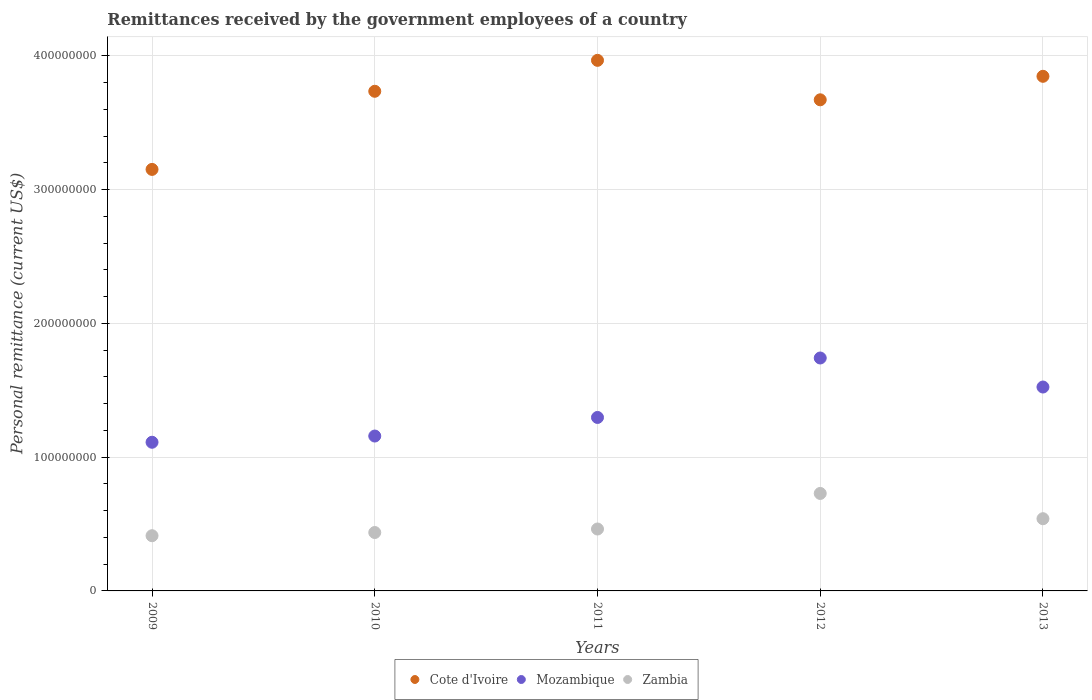How many different coloured dotlines are there?
Your response must be concise. 3. What is the remittances received by the government employees in Mozambique in 2013?
Give a very brief answer. 1.52e+08. Across all years, what is the maximum remittances received by the government employees in Cote d'Ivoire?
Provide a succinct answer. 3.97e+08. Across all years, what is the minimum remittances received by the government employees in Zambia?
Ensure brevity in your answer.  4.13e+07. In which year was the remittances received by the government employees in Zambia maximum?
Your answer should be very brief. 2012. What is the total remittances received by the government employees in Mozambique in the graph?
Give a very brief answer. 6.83e+08. What is the difference between the remittances received by the government employees in Mozambique in 2009 and that in 2012?
Keep it short and to the point. -6.30e+07. What is the difference between the remittances received by the government employees in Cote d'Ivoire in 2011 and the remittances received by the government employees in Zambia in 2012?
Your response must be concise. 3.24e+08. What is the average remittances received by the government employees in Zambia per year?
Offer a very short reply. 5.16e+07. In the year 2010, what is the difference between the remittances received by the government employees in Zambia and remittances received by the government employees in Cote d'Ivoire?
Ensure brevity in your answer.  -3.30e+08. In how many years, is the remittances received by the government employees in Cote d'Ivoire greater than 220000000 US$?
Keep it short and to the point. 5. What is the ratio of the remittances received by the government employees in Zambia in 2011 to that in 2013?
Ensure brevity in your answer.  0.86. Is the remittances received by the government employees in Cote d'Ivoire in 2010 less than that in 2012?
Offer a very short reply. No. Is the difference between the remittances received by the government employees in Zambia in 2009 and 2010 greater than the difference between the remittances received by the government employees in Cote d'Ivoire in 2009 and 2010?
Provide a short and direct response. Yes. What is the difference between the highest and the second highest remittances received by the government employees in Cote d'Ivoire?
Your answer should be very brief. 1.19e+07. What is the difference between the highest and the lowest remittances received by the government employees in Mozambique?
Provide a short and direct response. 6.30e+07. Is the remittances received by the government employees in Cote d'Ivoire strictly greater than the remittances received by the government employees in Mozambique over the years?
Your answer should be very brief. Yes. Is the remittances received by the government employees in Zambia strictly less than the remittances received by the government employees in Cote d'Ivoire over the years?
Your response must be concise. Yes. How many dotlines are there?
Your answer should be very brief. 3. How many years are there in the graph?
Your answer should be very brief. 5. What is the difference between two consecutive major ticks on the Y-axis?
Keep it short and to the point. 1.00e+08. Are the values on the major ticks of Y-axis written in scientific E-notation?
Provide a succinct answer. No. How many legend labels are there?
Offer a terse response. 3. How are the legend labels stacked?
Provide a short and direct response. Horizontal. What is the title of the graph?
Make the answer very short. Remittances received by the government employees of a country. What is the label or title of the Y-axis?
Offer a very short reply. Personal remittance (current US$). What is the Personal remittance (current US$) in Cote d'Ivoire in 2009?
Your response must be concise. 3.15e+08. What is the Personal remittance (current US$) of Mozambique in 2009?
Your response must be concise. 1.11e+08. What is the Personal remittance (current US$) in Zambia in 2009?
Your answer should be very brief. 4.13e+07. What is the Personal remittance (current US$) in Cote d'Ivoire in 2010?
Provide a succinct answer. 3.73e+08. What is the Personal remittance (current US$) in Mozambique in 2010?
Your answer should be compact. 1.16e+08. What is the Personal remittance (current US$) of Zambia in 2010?
Your answer should be compact. 4.37e+07. What is the Personal remittance (current US$) in Cote d'Ivoire in 2011?
Make the answer very short. 3.97e+08. What is the Personal remittance (current US$) of Mozambique in 2011?
Offer a terse response. 1.30e+08. What is the Personal remittance (current US$) in Zambia in 2011?
Provide a succinct answer. 4.63e+07. What is the Personal remittance (current US$) of Cote d'Ivoire in 2012?
Offer a terse response. 3.67e+08. What is the Personal remittance (current US$) in Mozambique in 2012?
Offer a terse response. 1.74e+08. What is the Personal remittance (current US$) in Zambia in 2012?
Provide a short and direct response. 7.29e+07. What is the Personal remittance (current US$) of Cote d'Ivoire in 2013?
Your answer should be compact. 3.85e+08. What is the Personal remittance (current US$) of Mozambique in 2013?
Offer a very short reply. 1.52e+08. What is the Personal remittance (current US$) of Zambia in 2013?
Give a very brief answer. 5.40e+07. Across all years, what is the maximum Personal remittance (current US$) in Cote d'Ivoire?
Provide a succinct answer. 3.97e+08. Across all years, what is the maximum Personal remittance (current US$) in Mozambique?
Your answer should be very brief. 1.74e+08. Across all years, what is the maximum Personal remittance (current US$) in Zambia?
Give a very brief answer. 7.29e+07. Across all years, what is the minimum Personal remittance (current US$) of Cote d'Ivoire?
Make the answer very short. 3.15e+08. Across all years, what is the minimum Personal remittance (current US$) in Mozambique?
Your answer should be compact. 1.11e+08. Across all years, what is the minimum Personal remittance (current US$) of Zambia?
Ensure brevity in your answer.  4.13e+07. What is the total Personal remittance (current US$) in Cote d'Ivoire in the graph?
Your response must be concise. 1.84e+09. What is the total Personal remittance (current US$) in Mozambique in the graph?
Offer a very short reply. 6.83e+08. What is the total Personal remittance (current US$) of Zambia in the graph?
Your answer should be very brief. 2.58e+08. What is the difference between the Personal remittance (current US$) in Cote d'Ivoire in 2009 and that in 2010?
Provide a succinct answer. -5.84e+07. What is the difference between the Personal remittance (current US$) of Mozambique in 2009 and that in 2010?
Keep it short and to the point. -4.65e+06. What is the difference between the Personal remittance (current US$) in Zambia in 2009 and that in 2010?
Your response must be concise. -2.39e+06. What is the difference between the Personal remittance (current US$) of Cote d'Ivoire in 2009 and that in 2011?
Offer a very short reply. -8.15e+07. What is the difference between the Personal remittance (current US$) in Mozambique in 2009 and that in 2011?
Provide a succinct answer. -1.85e+07. What is the difference between the Personal remittance (current US$) of Zambia in 2009 and that in 2011?
Keep it short and to the point. -5.01e+06. What is the difference between the Personal remittance (current US$) in Cote d'Ivoire in 2009 and that in 2012?
Your answer should be very brief. -5.20e+07. What is the difference between the Personal remittance (current US$) in Mozambique in 2009 and that in 2012?
Your answer should be compact. -6.30e+07. What is the difference between the Personal remittance (current US$) of Zambia in 2009 and that in 2012?
Provide a short and direct response. -3.16e+07. What is the difference between the Personal remittance (current US$) in Cote d'Ivoire in 2009 and that in 2013?
Provide a succinct answer. -6.96e+07. What is the difference between the Personal remittance (current US$) in Mozambique in 2009 and that in 2013?
Give a very brief answer. -4.13e+07. What is the difference between the Personal remittance (current US$) in Zambia in 2009 and that in 2013?
Offer a terse response. -1.27e+07. What is the difference between the Personal remittance (current US$) of Cote d'Ivoire in 2010 and that in 2011?
Provide a succinct answer. -2.31e+07. What is the difference between the Personal remittance (current US$) in Mozambique in 2010 and that in 2011?
Give a very brief answer. -1.39e+07. What is the difference between the Personal remittance (current US$) in Zambia in 2010 and that in 2011?
Offer a very short reply. -2.62e+06. What is the difference between the Personal remittance (current US$) in Cote d'Ivoire in 2010 and that in 2012?
Offer a terse response. 6.37e+06. What is the difference between the Personal remittance (current US$) of Mozambique in 2010 and that in 2012?
Keep it short and to the point. -5.83e+07. What is the difference between the Personal remittance (current US$) in Zambia in 2010 and that in 2012?
Provide a succinct answer. -2.92e+07. What is the difference between the Personal remittance (current US$) of Cote d'Ivoire in 2010 and that in 2013?
Make the answer very short. -1.12e+07. What is the difference between the Personal remittance (current US$) of Mozambique in 2010 and that in 2013?
Ensure brevity in your answer.  -3.66e+07. What is the difference between the Personal remittance (current US$) in Zambia in 2010 and that in 2013?
Give a very brief answer. -1.03e+07. What is the difference between the Personal remittance (current US$) of Cote d'Ivoire in 2011 and that in 2012?
Keep it short and to the point. 2.95e+07. What is the difference between the Personal remittance (current US$) in Mozambique in 2011 and that in 2012?
Your answer should be very brief. -4.44e+07. What is the difference between the Personal remittance (current US$) in Zambia in 2011 and that in 2012?
Offer a terse response. -2.66e+07. What is the difference between the Personal remittance (current US$) of Cote d'Ivoire in 2011 and that in 2013?
Make the answer very short. 1.19e+07. What is the difference between the Personal remittance (current US$) of Mozambique in 2011 and that in 2013?
Your answer should be compact. -2.27e+07. What is the difference between the Personal remittance (current US$) in Zambia in 2011 and that in 2013?
Offer a very short reply. -7.70e+06. What is the difference between the Personal remittance (current US$) of Cote d'Ivoire in 2012 and that in 2013?
Make the answer very short. -1.76e+07. What is the difference between the Personal remittance (current US$) in Mozambique in 2012 and that in 2013?
Your answer should be very brief. 2.17e+07. What is the difference between the Personal remittance (current US$) in Zambia in 2012 and that in 2013?
Offer a very short reply. 1.89e+07. What is the difference between the Personal remittance (current US$) of Cote d'Ivoire in 2009 and the Personal remittance (current US$) of Mozambique in 2010?
Your answer should be compact. 1.99e+08. What is the difference between the Personal remittance (current US$) of Cote d'Ivoire in 2009 and the Personal remittance (current US$) of Zambia in 2010?
Provide a short and direct response. 2.71e+08. What is the difference between the Personal remittance (current US$) in Mozambique in 2009 and the Personal remittance (current US$) in Zambia in 2010?
Your answer should be compact. 6.75e+07. What is the difference between the Personal remittance (current US$) in Cote d'Ivoire in 2009 and the Personal remittance (current US$) in Mozambique in 2011?
Ensure brevity in your answer.  1.85e+08. What is the difference between the Personal remittance (current US$) of Cote d'Ivoire in 2009 and the Personal remittance (current US$) of Zambia in 2011?
Your response must be concise. 2.69e+08. What is the difference between the Personal remittance (current US$) of Mozambique in 2009 and the Personal remittance (current US$) of Zambia in 2011?
Provide a short and direct response. 6.48e+07. What is the difference between the Personal remittance (current US$) of Cote d'Ivoire in 2009 and the Personal remittance (current US$) of Mozambique in 2012?
Make the answer very short. 1.41e+08. What is the difference between the Personal remittance (current US$) in Cote d'Ivoire in 2009 and the Personal remittance (current US$) in Zambia in 2012?
Your answer should be very brief. 2.42e+08. What is the difference between the Personal remittance (current US$) of Mozambique in 2009 and the Personal remittance (current US$) of Zambia in 2012?
Your answer should be very brief. 3.83e+07. What is the difference between the Personal remittance (current US$) in Cote d'Ivoire in 2009 and the Personal remittance (current US$) in Mozambique in 2013?
Offer a very short reply. 1.63e+08. What is the difference between the Personal remittance (current US$) in Cote d'Ivoire in 2009 and the Personal remittance (current US$) in Zambia in 2013?
Make the answer very short. 2.61e+08. What is the difference between the Personal remittance (current US$) of Mozambique in 2009 and the Personal remittance (current US$) of Zambia in 2013?
Give a very brief answer. 5.71e+07. What is the difference between the Personal remittance (current US$) of Cote d'Ivoire in 2010 and the Personal remittance (current US$) of Mozambique in 2011?
Ensure brevity in your answer.  2.44e+08. What is the difference between the Personal remittance (current US$) in Cote d'Ivoire in 2010 and the Personal remittance (current US$) in Zambia in 2011?
Offer a very short reply. 3.27e+08. What is the difference between the Personal remittance (current US$) of Mozambique in 2010 and the Personal remittance (current US$) of Zambia in 2011?
Ensure brevity in your answer.  6.95e+07. What is the difference between the Personal remittance (current US$) in Cote d'Ivoire in 2010 and the Personal remittance (current US$) in Mozambique in 2012?
Provide a succinct answer. 1.99e+08. What is the difference between the Personal remittance (current US$) in Cote d'Ivoire in 2010 and the Personal remittance (current US$) in Zambia in 2012?
Your answer should be compact. 3.01e+08. What is the difference between the Personal remittance (current US$) of Mozambique in 2010 and the Personal remittance (current US$) of Zambia in 2012?
Ensure brevity in your answer.  4.29e+07. What is the difference between the Personal remittance (current US$) of Cote d'Ivoire in 2010 and the Personal remittance (current US$) of Mozambique in 2013?
Your answer should be compact. 2.21e+08. What is the difference between the Personal remittance (current US$) of Cote d'Ivoire in 2010 and the Personal remittance (current US$) of Zambia in 2013?
Offer a very short reply. 3.19e+08. What is the difference between the Personal remittance (current US$) of Mozambique in 2010 and the Personal remittance (current US$) of Zambia in 2013?
Offer a very short reply. 6.18e+07. What is the difference between the Personal remittance (current US$) in Cote d'Ivoire in 2011 and the Personal remittance (current US$) in Mozambique in 2012?
Your response must be concise. 2.22e+08. What is the difference between the Personal remittance (current US$) in Cote d'Ivoire in 2011 and the Personal remittance (current US$) in Zambia in 2012?
Offer a very short reply. 3.24e+08. What is the difference between the Personal remittance (current US$) of Mozambique in 2011 and the Personal remittance (current US$) of Zambia in 2012?
Keep it short and to the point. 5.68e+07. What is the difference between the Personal remittance (current US$) in Cote d'Ivoire in 2011 and the Personal remittance (current US$) in Mozambique in 2013?
Offer a terse response. 2.44e+08. What is the difference between the Personal remittance (current US$) of Cote d'Ivoire in 2011 and the Personal remittance (current US$) of Zambia in 2013?
Keep it short and to the point. 3.43e+08. What is the difference between the Personal remittance (current US$) of Mozambique in 2011 and the Personal remittance (current US$) of Zambia in 2013?
Provide a short and direct response. 7.57e+07. What is the difference between the Personal remittance (current US$) in Cote d'Ivoire in 2012 and the Personal remittance (current US$) in Mozambique in 2013?
Ensure brevity in your answer.  2.15e+08. What is the difference between the Personal remittance (current US$) in Cote d'Ivoire in 2012 and the Personal remittance (current US$) in Zambia in 2013?
Offer a very short reply. 3.13e+08. What is the difference between the Personal remittance (current US$) of Mozambique in 2012 and the Personal remittance (current US$) of Zambia in 2013?
Provide a succinct answer. 1.20e+08. What is the average Personal remittance (current US$) of Cote d'Ivoire per year?
Give a very brief answer. 3.67e+08. What is the average Personal remittance (current US$) in Mozambique per year?
Give a very brief answer. 1.37e+08. What is the average Personal remittance (current US$) of Zambia per year?
Keep it short and to the point. 5.16e+07. In the year 2009, what is the difference between the Personal remittance (current US$) of Cote d'Ivoire and Personal remittance (current US$) of Mozambique?
Provide a short and direct response. 2.04e+08. In the year 2009, what is the difference between the Personal remittance (current US$) in Cote d'Ivoire and Personal remittance (current US$) in Zambia?
Provide a succinct answer. 2.74e+08. In the year 2009, what is the difference between the Personal remittance (current US$) in Mozambique and Personal remittance (current US$) in Zambia?
Your answer should be compact. 6.99e+07. In the year 2010, what is the difference between the Personal remittance (current US$) of Cote d'Ivoire and Personal remittance (current US$) of Mozambique?
Offer a terse response. 2.58e+08. In the year 2010, what is the difference between the Personal remittance (current US$) of Cote d'Ivoire and Personal remittance (current US$) of Zambia?
Offer a very short reply. 3.30e+08. In the year 2010, what is the difference between the Personal remittance (current US$) in Mozambique and Personal remittance (current US$) in Zambia?
Ensure brevity in your answer.  7.21e+07. In the year 2011, what is the difference between the Personal remittance (current US$) of Cote d'Ivoire and Personal remittance (current US$) of Mozambique?
Your response must be concise. 2.67e+08. In the year 2011, what is the difference between the Personal remittance (current US$) of Cote d'Ivoire and Personal remittance (current US$) of Zambia?
Your answer should be compact. 3.50e+08. In the year 2011, what is the difference between the Personal remittance (current US$) of Mozambique and Personal remittance (current US$) of Zambia?
Your response must be concise. 8.34e+07. In the year 2012, what is the difference between the Personal remittance (current US$) of Cote d'Ivoire and Personal remittance (current US$) of Mozambique?
Your answer should be compact. 1.93e+08. In the year 2012, what is the difference between the Personal remittance (current US$) in Cote d'Ivoire and Personal remittance (current US$) in Zambia?
Give a very brief answer. 2.94e+08. In the year 2012, what is the difference between the Personal remittance (current US$) in Mozambique and Personal remittance (current US$) in Zambia?
Your answer should be very brief. 1.01e+08. In the year 2013, what is the difference between the Personal remittance (current US$) of Cote d'Ivoire and Personal remittance (current US$) of Mozambique?
Ensure brevity in your answer.  2.32e+08. In the year 2013, what is the difference between the Personal remittance (current US$) in Cote d'Ivoire and Personal remittance (current US$) in Zambia?
Offer a terse response. 3.31e+08. In the year 2013, what is the difference between the Personal remittance (current US$) of Mozambique and Personal remittance (current US$) of Zambia?
Your answer should be compact. 9.84e+07. What is the ratio of the Personal remittance (current US$) of Cote d'Ivoire in 2009 to that in 2010?
Make the answer very short. 0.84. What is the ratio of the Personal remittance (current US$) of Mozambique in 2009 to that in 2010?
Your answer should be very brief. 0.96. What is the ratio of the Personal remittance (current US$) of Zambia in 2009 to that in 2010?
Provide a short and direct response. 0.95. What is the ratio of the Personal remittance (current US$) in Cote d'Ivoire in 2009 to that in 2011?
Provide a succinct answer. 0.79. What is the ratio of the Personal remittance (current US$) of Mozambique in 2009 to that in 2011?
Provide a short and direct response. 0.86. What is the ratio of the Personal remittance (current US$) of Zambia in 2009 to that in 2011?
Your answer should be very brief. 0.89. What is the ratio of the Personal remittance (current US$) of Cote d'Ivoire in 2009 to that in 2012?
Your answer should be very brief. 0.86. What is the ratio of the Personal remittance (current US$) of Mozambique in 2009 to that in 2012?
Offer a very short reply. 0.64. What is the ratio of the Personal remittance (current US$) of Zambia in 2009 to that in 2012?
Your response must be concise. 0.57. What is the ratio of the Personal remittance (current US$) in Cote d'Ivoire in 2009 to that in 2013?
Your answer should be compact. 0.82. What is the ratio of the Personal remittance (current US$) of Mozambique in 2009 to that in 2013?
Make the answer very short. 0.73. What is the ratio of the Personal remittance (current US$) in Zambia in 2009 to that in 2013?
Your response must be concise. 0.76. What is the ratio of the Personal remittance (current US$) of Cote d'Ivoire in 2010 to that in 2011?
Keep it short and to the point. 0.94. What is the ratio of the Personal remittance (current US$) of Mozambique in 2010 to that in 2011?
Give a very brief answer. 0.89. What is the ratio of the Personal remittance (current US$) of Zambia in 2010 to that in 2011?
Provide a short and direct response. 0.94. What is the ratio of the Personal remittance (current US$) in Cote d'Ivoire in 2010 to that in 2012?
Provide a short and direct response. 1.02. What is the ratio of the Personal remittance (current US$) in Mozambique in 2010 to that in 2012?
Your answer should be compact. 0.67. What is the ratio of the Personal remittance (current US$) of Zambia in 2010 to that in 2012?
Make the answer very short. 0.6. What is the ratio of the Personal remittance (current US$) of Cote d'Ivoire in 2010 to that in 2013?
Your response must be concise. 0.97. What is the ratio of the Personal remittance (current US$) of Mozambique in 2010 to that in 2013?
Give a very brief answer. 0.76. What is the ratio of the Personal remittance (current US$) in Zambia in 2010 to that in 2013?
Provide a succinct answer. 0.81. What is the ratio of the Personal remittance (current US$) in Cote d'Ivoire in 2011 to that in 2012?
Your answer should be very brief. 1.08. What is the ratio of the Personal remittance (current US$) of Mozambique in 2011 to that in 2012?
Give a very brief answer. 0.74. What is the ratio of the Personal remittance (current US$) in Zambia in 2011 to that in 2012?
Offer a terse response. 0.64. What is the ratio of the Personal remittance (current US$) in Cote d'Ivoire in 2011 to that in 2013?
Provide a short and direct response. 1.03. What is the ratio of the Personal remittance (current US$) in Mozambique in 2011 to that in 2013?
Your response must be concise. 0.85. What is the ratio of the Personal remittance (current US$) in Zambia in 2011 to that in 2013?
Offer a terse response. 0.86. What is the ratio of the Personal remittance (current US$) of Cote d'Ivoire in 2012 to that in 2013?
Your response must be concise. 0.95. What is the ratio of the Personal remittance (current US$) of Mozambique in 2012 to that in 2013?
Make the answer very short. 1.14. What is the ratio of the Personal remittance (current US$) in Zambia in 2012 to that in 2013?
Offer a very short reply. 1.35. What is the difference between the highest and the second highest Personal remittance (current US$) of Cote d'Ivoire?
Offer a very short reply. 1.19e+07. What is the difference between the highest and the second highest Personal remittance (current US$) in Mozambique?
Keep it short and to the point. 2.17e+07. What is the difference between the highest and the second highest Personal remittance (current US$) in Zambia?
Keep it short and to the point. 1.89e+07. What is the difference between the highest and the lowest Personal remittance (current US$) in Cote d'Ivoire?
Give a very brief answer. 8.15e+07. What is the difference between the highest and the lowest Personal remittance (current US$) of Mozambique?
Provide a short and direct response. 6.30e+07. What is the difference between the highest and the lowest Personal remittance (current US$) of Zambia?
Ensure brevity in your answer.  3.16e+07. 